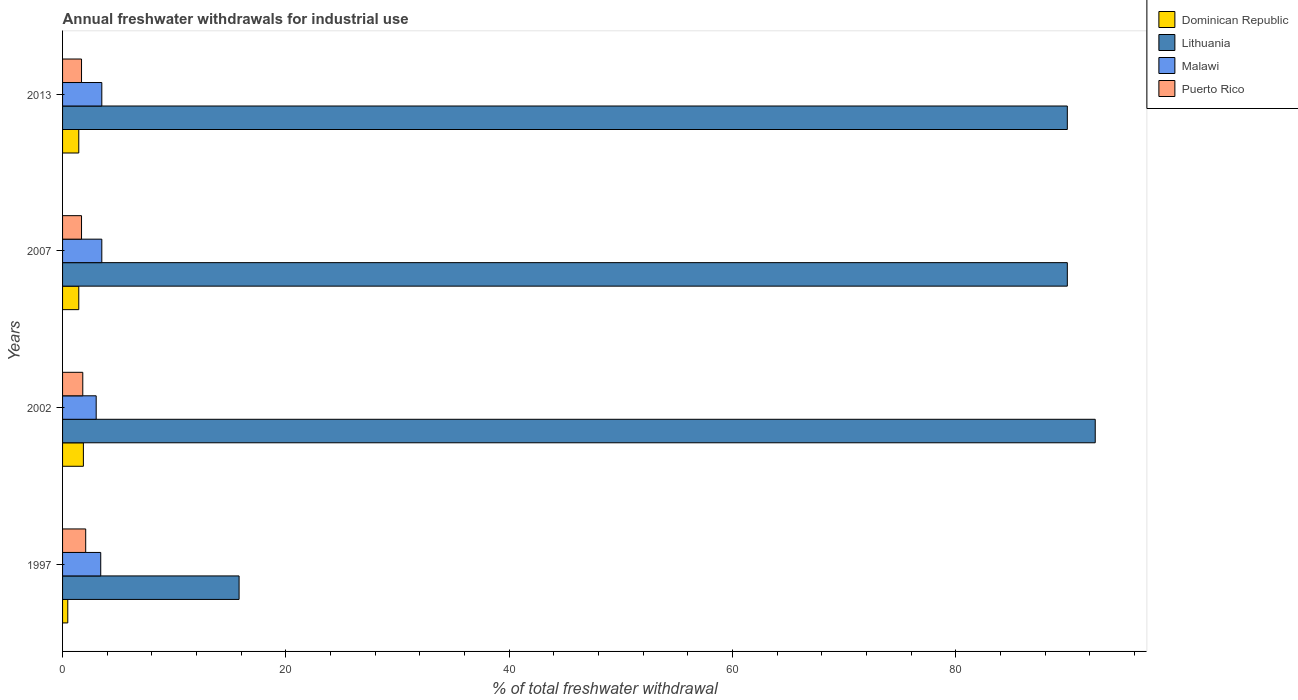How many different coloured bars are there?
Offer a very short reply. 4. Are the number of bars per tick equal to the number of legend labels?
Make the answer very short. Yes. What is the total annual withdrawals from freshwater in Lithuania in 2002?
Make the answer very short. 92.49. Across all years, what is the maximum total annual withdrawals from freshwater in Puerto Rico?
Give a very brief answer. 2.07. Across all years, what is the minimum total annual withdrawals from freshwater in Malawi?
Your response must be concise. 3.01. In which year was the total annual withdrawals from freshwater in Lithuania maximum?
Ensure brevity in your answer.  2002. In which year was the total annual withdrawals from freshwater in Puerto Rico minimum?
Ensure brevity in your answer.  2007. What is the total total annual withdrawals from freshwater in Puerto Rico in the graph?
Offer a terse response. 7.28. What is the difference between the total annual withdrawals from freshwater in Malawi in 2007 and that in 2013?
Offer a very short reply. 0. What is the difference between the total annual withdrawals from freshwater in Malawi in 2007 and the total annual withdrawals from freshwater in Dominican Republic in 2002?
Your answer should be very brief. 1.65. What is the average total annual withdrawals from freshwater in Dominican Republic per year?
Offer a very short reply. 1.31. In the year 2007, what is the difference between the total annual withdrawals from freshwater in Malawi and total annual withdrawals from freshwater in Lithuania?
Your answer should be compact. -86.47. What is the difference between the highest and the second highest total annual withdrawals from freshwater in Puerto Rico?
Offer a very short reply. 0.26. What is the difference between the highest and the lowest total annual withdrawals from freshwater in Lithuania?
Ensure brevity in your answer.  76.68. In how many years, is the total annual withdrawals from freshwater in Malawi greater than the average total annual withdrawals from freshwater in Malawi taken over all years?
Provide a succinct answer. 3. Is it the case that in every year, the sum of the total annual withdrawals from freshwater in Dominican Republic and total annual withdrawals from freshwater in Lithuania is greater than the sum of total annual withdrawals from freshwater in Malawi and total annual withdrawals from freshwater in Puerto Rico?
Keep it short and to the point. No. What does the 4th bar from the top in 2013 represents?
Ensure brevity in your answer.  Dominican Republic. What does the 3rd bar from the bottom in 2013 represents?
Ensure brevity in your answer.  Malawi. Are all the bars in the graph horizontal?
Ensure brevity in your answer.  Yes. How many years are there in the graph?
Make the answer very short. 4. Does the graph contain any zero values?
Provide a succinct answer. No. Does the graph contain grids?
Offer a very short reply. No. How are the legend labels stacked?
Offer a very short reply. Vertical. What is the title of the graph?
Make the answer very short. Annual freshwater withdrawals for industrial use. Does "Iceland" appear as one of the legend labels in the graph?
Your response must be concise. No. What is the label or title of the X-axis?
Give a very brief answer. % of total freshwater withdrawal. What is the label or title of the Y-axis?
Give a very brief answer. Years. What is the % of total freshwater withdrawal of Dominican Republic in 1997?
Provide a succinct answer. 0.47. What is the % of total freshwater withdrawal in Lithuania in 1997?
Give a very brief answer. 15.81. What is the % of total freshwater withdrawal of Malawi in 1997?
Your response must be concise. 3.42. What is the % of total freshwater withdrawal in Puerto Rico in 1997?
Your response must be concise. 2.07. What is the % of total freshwater withdrawal in Dominican Republic in 2002?
Offer a very short reply. 1.86. What is the % of total freshwater withdrawal in Lithuania in 2002?
Ensure brevity in your answer.  92.49. What is the % of total freshwater withdrawal of Malawi in 2002?
Give a very brief answer. 3.01. What is the % of total freshwater withdrawal of Puerto Rico in 2002?
Offer a very short reply. 1.81. What is the % of total freshwater withdrawal of Dominican Republic in 2007?
Provide a short and direct response. 1.45. What is the % of total freshwater withdrawal of Lithuania in 2007?
Provide a short and direct response. 89.99. What is the % of total freshwater withdrawal in Malawi in 2007?
Your answer should be very brief. 3.52. What is the % of total freshwater withdrawal in Puerto Rico in 2007?
Provide a short and direct response. 1.7. What is the % of total freshwater withdrawal in Dominican Republic in 2013?
Make the answer very short. 1.45. What is the % of total freshwater withdrawal in Lithuania in 2013?
Your answer should be very brief. 89.99. What is the % of total freshwater withdrawal of Malawi in 2013?
Keep it short and to the point. 3.52. What is the % of total freshwater withdrawal of Puerto Rico in 2013?
Keep it short and to the point. 1.7. Across all years, what is the maximum % of total freshwater withdrawal of Dominican Republic?
Ensure brevity in your answer.  1.86. Across all years, what is the maximum % of total freshwater withdrawal in Lithuania?
Keep it short and to the point. 92.49. Across all years, what is the maximum % of total freshwater withdrawal of Malawi?
Your answer should be very brief. 3.52. Across all years, what is the maximum % of total freshwater withdrawal in Puerto Rico?
Offer a very short reply. 2.07. Across all years, what is the minimum % of total freshwater withdrawal in Dominican Republic?
Your response must be concise. 0.47. Across all years, what is the minimum % of total freshwater withdrawal of Lithuania?
Give a very brief answer. 15.81. Across all years, what is the minimum % of total freshwater withdrawal of Malawi?
Keep it short and to the point. 3.01. Across all years, what is the minimum % of total freshwater withdrawal of Puerto Rico?
Make the answer very short. 1.7. What is the total % of total freshwater withdrawal of Dominican Republic in the graph?
Provide a short and direct response. 5.24. What is the total % of total freshwater withdrawal of Lithuania in the graph?
Your answer should be compact. 288.28. What is the total % of total freshwater withdrawal in Malawi in the graph?
Offer a terse response. 13.46. What is the total % of total freshwater withdrawal of Puerto Rico in the graph?
Your answer should be compact. 7.28. What is the difference between the % of total freshwater withdrawal of Dominican Republic in 1997 and that in 2002?
Offer a terse response. -1.4. What is the difference between the % of total freshwater withdrawal in Lithuania in 1997 and that in 2002?
Keep it short and to the point. -76.68. What is the difference between the % of total freshwater withdrawal of Malawi in 1997 and that in 2002?
Your answer should be very brief. 0.41. What is the difference between the % of total freshwater withdrawal of Puerto Rico in 1997 and that in 2002?
Your answer should be very brief. 0.26. What is the difference between the % of total freshwater withdrawal of Dominican Republic in 1997 and that in 2007?
Your answer should be very brief. -0.99. What is the difference between the % of total freshwater withdrawal in Lithuania in 1997 and that in 2007?
Your answer should be compact. -74.18. What is the difference between the % of total freshwater withdrawal of Malawi in 1997 and that in 2007?
Ensure brevity in your answer.  -0.1. What is the difference between the % of total freshwater withdrawal of Puerto Rico in 1997 and that in 2007?
Offer a terse response. 0.37. What is the difference between the % of total freshwater withdrawal of Dominican Republic in 1997 and that in 2013?
Keep it short and to the point. -0.99. What is the difference between the % of total freshwater withdrawal of Lithuania in 1997 and that in 2013?
Provide a short and direct response. -74.18. What is the difference between the % of total freshwater withdrawal of Malawi in 1997 and that in 2013?
Ensure brevity in your answer.  -0.1. What is the difference between the % of total freshwater withdrawal of Puerto Rico in 1997 and that in 2013?
Provide a short and direct response. 0.37. What is the difference between the % of total freshwater withdrawal of Dominican Republic in 2002 and that in 2007?
Ensure brevity in your answer.  0.41. What is the difference between the % of total freshwater withdrawal in Lithuania in 2002 and that in 2007?
Provide a short and direct response. 2.5. What is the difference between the % of total freshwater withdrawal of Malawi in 2002 and that in 2007?
Provide a short and direct response. -0.5. What is the difference between the % of total freshwater withdrawal in Puerto Rico in 2002 and that in 2007?
Keep it short and to the point. 0.11. What is the difference between the % of total freshwater withdrawal of Dominican Republic in 2002 and that in 2013?
Make the answer very short. 0.41. What is the difference between the % of total freshwater withdrawal of Malawi in 2002 and that in 2013?
Ensure brevity in your answer.  -0.5. What is the difference between the % of total freshwater withdrawal in Puerto Rico in 2002 and that in 2013?
Keep it short and to the point. 0.11. What is the difference between the % of total freshwater withdrawal of Dominican Republic in 2007 and that in 2013?
Ensure brevity in your answer.  0. What is the difference between the % of total freshwater withdrawal in Lithuania in 2007 and that in 2013?
Your answer should be very brief. 0. What is the difference between the % of total freshwater withdrawal in Puerto Rico in 2007 and that in 2013?
Make the answer very short. 0. What is the difference between the % of total freshwater withdrawal of Dominican Republic in 1997 and the % of total freshwater withdrawal of Lithuania in 2002?
Ensure brevity in your answer.  -92.02. What is the difference between the % of total freshwater withdrawal of Dominican Republic in 1997 and the % of total freshwater withdrawal of Malawi in 2002?
Offer a very short reply. -2.54. What is the difference between the % of total freshwater withdrawal in Dominican Republic in 1997 and the % of total freshwater withdrawal in Puerto Rico in 2002?
Keep it short and to the point. -1.34. What is the difference between the % of total freshwater withdrawal of Lithuania in 1997 and the % of total freshwater withdrawal of Malawi in 2002?
Your answer should be compact. 12.8. What is the difference between the % of total freshwater withdrawal in Malawi in 1997 and the % of total freshwater withdrawal in Puerto Rico in 2002?
Make the answer very short. 1.61. What is the difference between the % of total freshwater withdrawal of Dominican Republic in 1997 and the % of total freshwater withdrawal of Lithuania in 2007?
Make the answer very short. -89.52. What is the difference between the % of total freshwater withdrawal of Dominican Republic in 1997 and the % of total freshwater withdrawal of Malawi in 2007?
Keep it short and to the point. -3.05. What is the difference between the % of total freshwater withdrawal of Dominican Republic in 1997 and the % of total freshwater withdrawal of Puerto Rico in 2007?
Keep it short and to the point. -1.23. What is the difference between the % of total freshwater withdrawal in Lithuania in 1997 and the % of total freshwater withdrawal in Malawi in 2007?
Your response must be concise. 12.29. What is the difference between the % of total freshwater withdrawal in Lithuania in 1997 and the % of total freshwater withdrawal in Puerto Rico in 2007?
Your answer should be very brief. 14.11. What is the difference between the % of total freshwater withdrawal in Malawi in 1997 and the % of total freshwater withdrawal in Puerto Rico in 2007?
Ensure brevity in your answer.  1.72. What is the difference between the % of total freshwater withdrawal in Dominican Republic in 1997 and the % of total freshwater withdrawal in Lithuania in 2013?
Give a very brief answer. -89.52. What is the difference between the % of total freshwater withdrawal in Dominican Republic in 1997 and the % of total freshwater withdrawal in Malawi in 2013?
Your answer should be very brief. -3.05. What is the difference between the % of total freshwater withdrawal in Dominican Republic in 1997 and the % of total freshwater withdrawal in Puerto Rico in 2013?
Offer a very short reply. -1.23. What is the difference between the % of total freshwater withdrawal of Lithuania in 1997 and the % of total freshwater withdrawal of Malawi in 2013?
Keep it short and to the point. 12.29. What is the difference between the % of total freshwater withdrawal of Lithuania in 1997 and the % of total freshwater withdrawal of Puerto Rico in 2013?
Provide a short and direct response. 14.11. What is the difference between the % of total freshwater withdrawal in Malawi in 1997 and the % of total freshwater withdrawal in Puerto Rico in 2013?
Give a very brief answer. 1.72. What is the difference between the % of total freshwater withdrawal of Dominican Republic in 2002 and the % of total freshwater withdrawal of Lithuania in 2007?
Offer a terse response. -88.12. What is the difference between the % of total freshwater withdrawal of Dominican Republic in 2002 and the % of total freshwater withdrawal of Malawi in 2007?
Ensure brevity in your answer.  -1.65. What is the difference between the % of total freshwater withdrawal of Dominican Republic in 2002 and the % of total freshwater withdrawal of Puerto Rico in 2007?
Your answer should be compact. 0.17. What is the difference between the % of total freshwater withdrawal in Lithuania in 2002 and the % of total freshwater withdrawal in Malawi in 2007?
Offer a very short reply. 88.97. What is the difference between the % of total freshwater withdrawal of Lithuania in 2002 and the % of total freshwater withdrawal of Puerto Rico in 2007?
Keep it short and to the point. 90.79. What is the difference between the % of total freshwater withdrawal in Malawi in 2002 and the % of total freshwater withdrawal in Puerto Rico in 2007?
Offer a terse response. 1.31. What is the difference between the % of total freshwater withdrawal in Dominican Republic in 2002 and the % of total freshwater withdrawal in Lithuania in 2013?
Ensure brevity in your answer.  -88.12. What is the difference between the % of total freshwater withdrawal of Dominican Republic in 2002 and the % of total freshwater withdrawal of Malawi in 2013?
Make the answer very short. -1.65. What is the difference between the % of total freshwater withdrawal of Dominican Republic in 2002 and the % of total freshwater withdrawal of Puerto Rico in 2013?
Your answer should be compact. 0.17. What is the difference between the % of total freshwater withdrawal of Lithuania in 2002 and the % of total freshwater withdrawal of Malawi in 2013?
Make the answer very short. 88.97. What is the difference between the % of total freshwater withdrawal of Lithuania in 2002 and the % of total freshwater withdrawal of Puerto Rico in 2013?
Offer a terse response. 90.79. What is the difference between the % of total freshwater withdrawal of Malawi in 2002 and the % of total freshwater withdrawal of Puerto Rico in 2013?
Give a very brief answer. 1.31. What is the difference between the % of total freshwater withdrawal of Dominican Republic in 2007 and the % of total freshwater withdrawal of Lithuania in 2013?
Give a very brief answer. -88.54. What is the difference between the % of total freshwater withdrawal of Dominican Republic in 2007 and the % of total freshwater withdrawal of Malawi in 2013?
Your answer should be very brief. -2.06. What is the difference between the % of total freshwater withdrawal in Dominican Republic in 2007 and the % of total freshwater withdrawal in Puerto Rico in 2013?
Provide a short and direct response. -0.24. What is the difference between the % of total freshwater withdrawal in Lithuania in 2007 and the % of total freshwater withdrawal in Malawi in 2013?
Your answer should be very brief. 86.47. What is the difference between the % of total freshwater withdrawal of Lithuania in 2007 and the % of total freshwater withdrawal of Puerto Rico in 2013?
Provide a short and direct response. 88.29. What is the difference between the % of total freshwater withdrawal of Malawi in 2007 and the % of total freshwater withdrawal of Puerto Rico in 2013?
Provide a succinct answer. 1.82. What is the average % of total freshwater withdrawal in Dominican Republic per year?
Provide a succinct answer. 1.31. What is the average % of total freshwater withdrawal of Lithuania per year?
Provide a succinct answer. 72.07. What is the average % of total freshwater withdrawal in Malawi per year?
Give a very brief answer. 3.37. What is the average % of total freshwater withdrawal in Puerto Rico per year?
Your answer should be very brief. 1.82. In the year 1997, what is the difference between the % of total freshwater withdrawal in Dominican Republic and % of total freshwater withdrawal in Lithuania?
Ensure brevity in your answer.  -15.34. In the year 1997, what is the difference between the % of total freshwater withdrawal in Dominican Republic and % of total freshwater withdrawal in Malawi?
Your answer should be very brief. -2.95. In the year 1997, what is the difference between the % of total freshwater withdrawal in Dominican Republic and % of total freshwater withdrawal in Puerto Rico?
Your answer should be very brief. -1.6. In the year 1997, what is the difference between the % of total freshwater withdrawal in Lithuania and % of total freshwater withdrawal in Malawi?
Make the answer very short. 12.39. In the year 1997, what is the difference between the % of total freshwater withdrawal of Lithuania and % of total freshwater withdrawal of Puerto Rico?
Your answer should be very brief. 13.74. In the year 1997, what is the difference between the % of total freshwater withdrawal of Malawi and % of total freshwater withdrawal of Puerto Rico?
Offer a terse response. 1.35. In the year 2002, what is the difference between the % of total freshwater withdrawal of Dominican Republic and % of total freshwater withdrawal of Lithuania?
Offer a terse response. -90.62. In the year 2002, what is the difference between the % of total freshwater withdrawal of Dominican Republic and % of total freshwater withdrawal of Malawi?
Provide a short and direct response. -1.15. In the year 2002, what is the difference between the % of total freshwater withdrawal in Dominican Republic and % of total freshwater withdrawal in Puerto Rico?
Your answer should be very brief. 0.06. In the year 2002, what is the difference between the % of total freshwater withdrawal of Lithuania and % of total freshwater withdrawal of Malawi?
Give a very brief answer. 89.48. In the year 2002, what is the difference between the % of total freshwater withdrawal of Lithuania and % of total freshwater withdrawal of Puerto Rico?
Your answer should be compact. 90.68. In the year 2002, what is the difference between the % of total freshwater withdrawal of Malawi and % of total freshwater withdrawal of Puerto Rico?
Make the answer very short. 1.2. In the year 2007, what is the difference between the % of total freshwater withdrawal of Dominican Republic and % of total freshwater withdrawal of Lithuania?
Provide a short and direct response. -88.54. In the year 2007, what is the difference between the % of total freshwater withdrawal in Dominican Republic and % of total freshwater withdrawal in Malawi?
Provide a short and direct response. -2.06. In the year 2007, what is the difference between the % of total freshwater withdrawal of Dominican Republic and % of total freshwater withdrawal of Puerto Rico?
Provide a succinct answer. -0.24. In the year 2007, what is the difference between the % of total freshwater withdrawal of Lithuania and % of total freshwater withdrawal of Malawi?
Offer a very short reply. 86.47. In the year 2007, what is the difference between the % of total freshwater withdrawal in Lithuania and % of total freshwater withdrawal in Puerto Rico?
Your answer should be compact. 88.29. In the year 2007, what is the difference between the % of total freshwater withdrawal of Malawi and % of total freshwater withdrawal of Puerto Rico?
Offer a very short reply. 1.82. In the year 2013, what is the difference between the % of total freshwater withdrawal of Dominican Republic and % of total freshwater withdrawal of Lithuania?
Give a very brief answer. -88.54. In the year 2013, what is the difference between the % of total freshwater withdrawal of Dominican Republic and % of total freshwater withdrawal of Malawi?
Make the answer very short. -2.06. In the year 2013, what is the difference between the % of total freshwater withdrawal in Dominican Republic and % of total freshwater withdrawal in Puerto Rico?
Make the answer very short. -0.24. In the year 2013, what is the difference between the % of total freshwater withdrawal in Lithuania and % of total freshwater withdrawal in Malawi?
Make the answer very short. 86.47. In the year 2013, what is the difference between the % of total freshwater withdrawal of Lithuania and % of total freshwater withdrawal of Puerto Rico?
Give a very brief answer. 88.29. In the year 2013, what is the difference between the % of total freshwater withdrawal of Malawi and % of total freshwater withdrawal of Puerto Rico?
Offer a terse response. 1.82. What is the ratio of the % of total freshwater withdrawal in Dominican Republic in 1997 to that in 2002?
Your response must be concise. 0.25. What is the ratio of the % of total freshwater withdrawal in Lithuania in 1997 to that in 2002?
Give a very brief answer. 0.17. What is the ratio of the % of total freshwater withdrawal of Malawi in 1997 to that in 2002?
Give a very brief answer. 1.14. What is the ratio of the % of total freshwater withdrawal in Puerto Rico in 1997 to that in 2002?
Give a very brief answer. 1.14. What is the ratio of the % of total freshwater withdrawal of Dominican Republic in 1997 to that in 2007?
Offer a very short reply. 0.32. What is the ratio of the % of total freshwater withdrawal in Lithuania in 1997 to that in 2007?
Ensure brevity in your answer.  0.18. What is the ratio of the % of total freshwater withdrawal of Malawi in 1997 to that in 2007?
Provide a short and direct response. 0.97. What is the ratio of the % of total freshwater withdrawal of Puerto Rico in 1997 to that in 2007?
Ensure brevity in your answer.  1.22. What is the ratio of the % of total freshwater withdrawal in Dominican Republic in 1997 to that in 2013?
Provide a succinct answer. 0.32. What is the ratio of the % of total freshwater withdrawal of Lithuania in 1997 to that in 2013?
Your answer should be compact. 0.18. What is the ratio of the % of total freshwater withdrawal in Malawi in 1997 to that in 2013?
Your response must be concise. 0.97. What is the ratio of the % of total freshwater withdrawal in Puerto Rico in 1997 to that in 2013?
Ensure brevity in your answer.  1.22. What is the ratio of the % of total freshwater withdrawal in Dominican Republic in 2002 to that in 2007?
Provide a succinct answer. 1.28. What is the ratio of the % of total freshwater withdrawal of Lithuania in 2002 to that in 2007?
Offer a very short reply. 1.03. What is the ratio of the % of total freshwater withdrawal in Malawi in 2002 to that in 2007?
Provide a succinct answer. 0.86. What is the ratio of the % of total freshwater withdrawal in Puerto Rico in 2002 to that in 2007?
Your answer should be very brief. 1.07. What is the ratio of the % of total freshwater withdrawal in Dominican Republic in 2002 to that in 2013?
Provide a succinct answer. 1.28. What is the ratio of the % of total freshwater withdrawal of Lithuania in 2002 to that in 2013?
Provide a succinct answer. 1.03. What is the ratio of the % of total freshwater withdrawal of Malawi in 2002 to that in 2013?
Provide a short and direct response. 0.86. What is the ratio of the % of total freshwater withdrawal in Puerto Rico in 2002 to that in 2013?
Your answer should be compact. 1.07. What is the ratio of the % of total freshwater withdrawal in Malawi in 2007 to that in 2013?
Keep it short and to the point. 1. What is the difference between the highest and the second highest % of total freshwater withdrawal of Dominican Republic?
Keep it short and to the point. 0.41. What is the difference between the highest and the second highest % of total freshwater withdrawal of Puerto Rico?
Ensure brevity in your answer.  0.26. What is the difference between the highest and the lowest % of total freshwater withdrawal in Dominican Republic?
Your response must be concise. 1.4. What is the difference between the highest and the lowest % of total freshwater withdrawal of Lithuania?
Keep it short and to the point. 76.68. What is the difference between the highest and the lowest % of total freshwater withdrawal of Malawi?
Keep it short and to the point. 0.5. What is the difference between the highest and the lowest % of total freshwater withdrawal of Puerto Rico?
Keep it short and to the point. 0.37. 